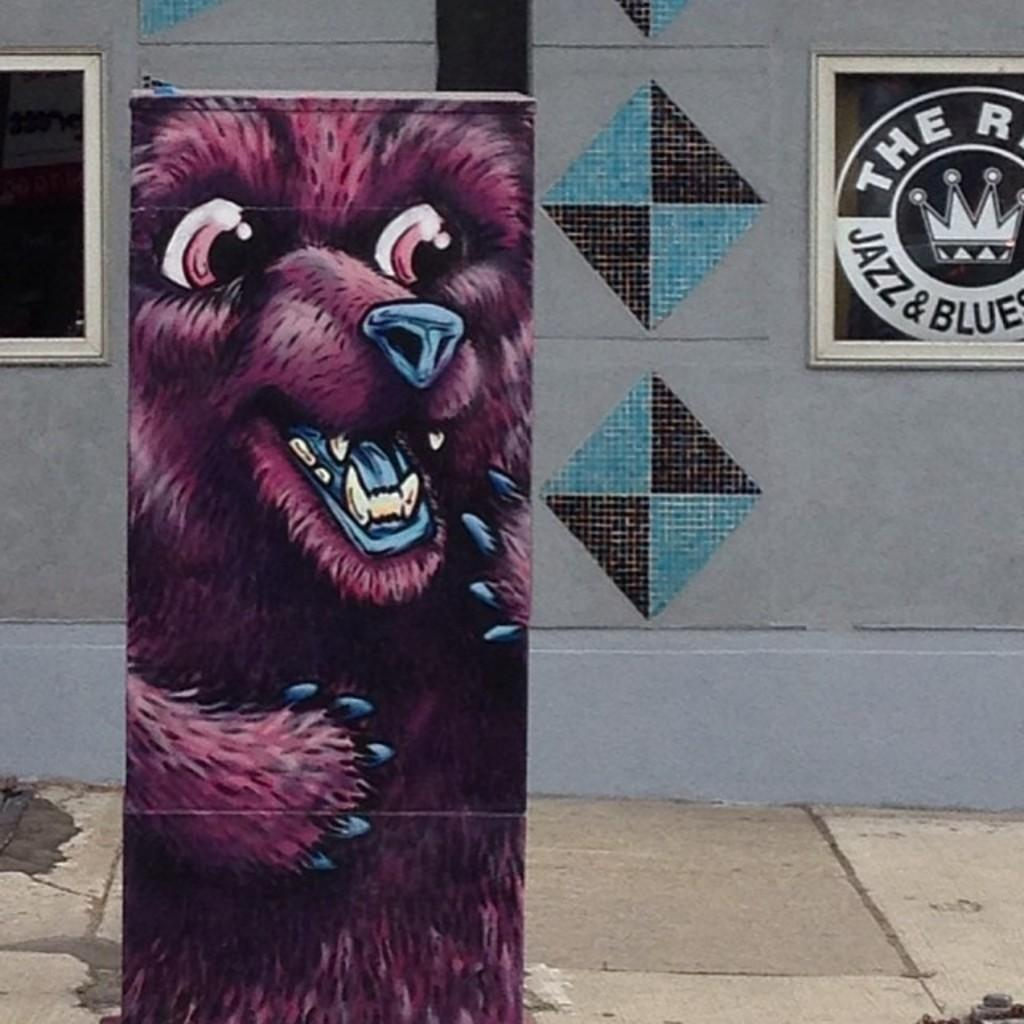What type of artwork is on the wall in the image? There is a painting of a purple bear on a wall in the image. Can you describe the layout of the walls in the image? There is another wall with a painting behind the wall with the purple bear painting. What is visible through the window in the image? The window is in front of a footpath. What type of kitty can be seen playing with a fang in the image? There is no kitty or fang present in the image; it features a painting of a purple bear and a window with a footpath. Is there any dirt visible in the image? There is no mention of dirt in the provided facts, so it cannot be determined if dirt is present in the image. 